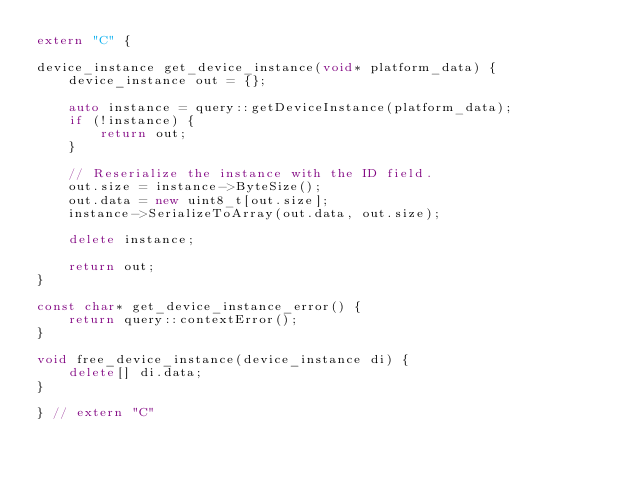Convert code to text. <code><loc_0><loc_0><loc_500><loc_500><_C++_>extern "C" {

device_instance get_device_instance(void* platform_data) {
    device_instance out = {};

    auto instance = query::getDeviceInstance(platform_data);
    if (!instance) {
        return out;
    }

    // Reserialize the instance with the ID field.
    out.size = instance->ByteSize();
    out.data = new uint8_t[out.size];
    instance->SerializeToArray(out.data, out.size);

    delete instance;

    return out;
}

const char* get_device_instance_error() {
    return query::contextError();
}

void free_device_instance(device_instance di) {
    delete[] di.data;
}

} // extern "C"
</code> 